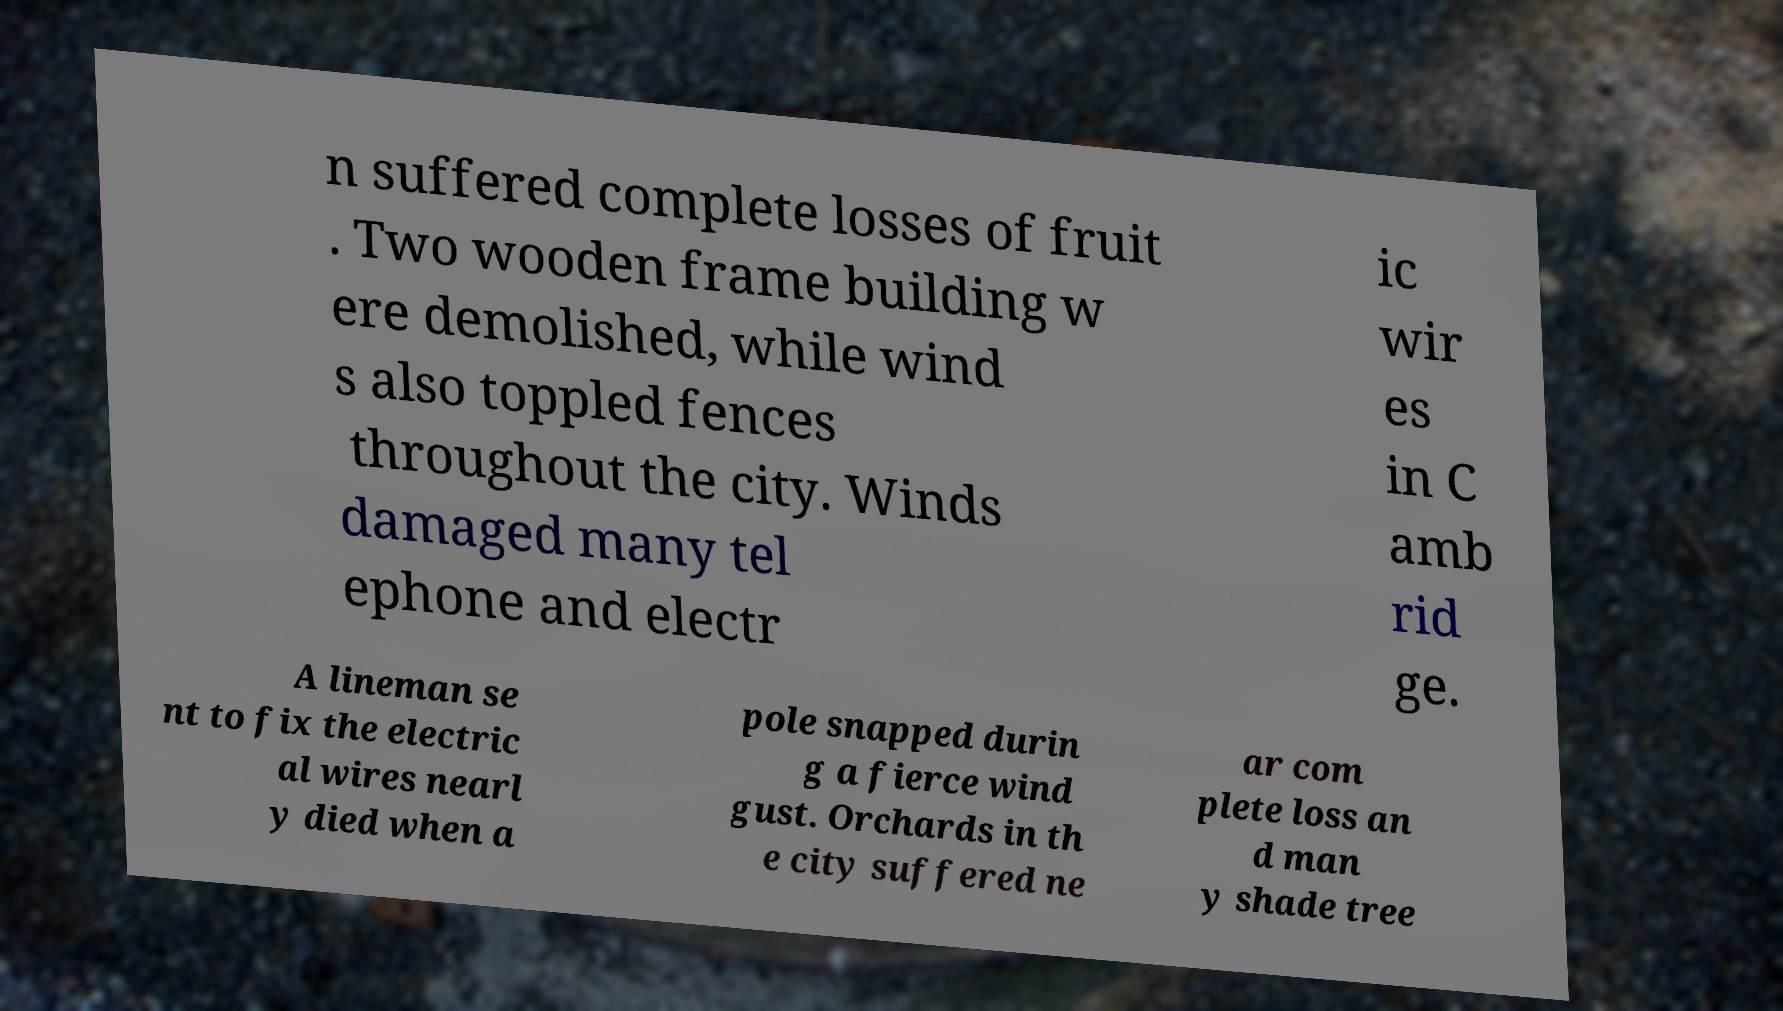Can you accurately transcribe the text from the provided image for me? n suffered complete losses of fruit . Two wooden frame building w ere demolished, while wind s also toppled fences throughout the city. Winds damaged many tel ephone and electr ic wir es in C amb rid ge. A lineman se nt to fix the electric al wires nearl y died when a pole snapped durin g a fierce wind gust. Orchards in th e city suffered ne ar com plete loss an d man y shade tree 